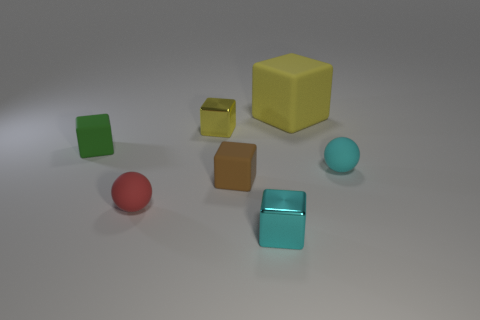Is there any other thing that has the same size as the yellow rubber block?
Your answer should be very brief. No. Are there the same number of tiny matte balls that are right of the big yellow rubber block and small yellow blocks?
Keep it short and to the point. Yes. What size is the thing that is on the right side of the brown rubber object and behind the tiny green cube?
Your answer should be very brief. Large. Is there any other thing of the same color as the large matte block?
Make the answer very short. Yes. How big is the metal thing right of the metal block that is behind the tiny green object?
Give a very brief answer. Small. There is a small block that is both in front of the green matte thing and behind the red sphere; what color is it?
Your answer should be compact. Brown. How many other things are the same size as the yellow shiny object?
Make the answer very short. 5. Does the green block have the same size as the metal cube that is behind the green thing?
Offer a very short reply. Yes. There is a rubber cube that is the same size as the brown rubber thing; what color is it?
Your response must be concise. Green. The yellow matte cube has what size?
Give a very brief answer. Large. 